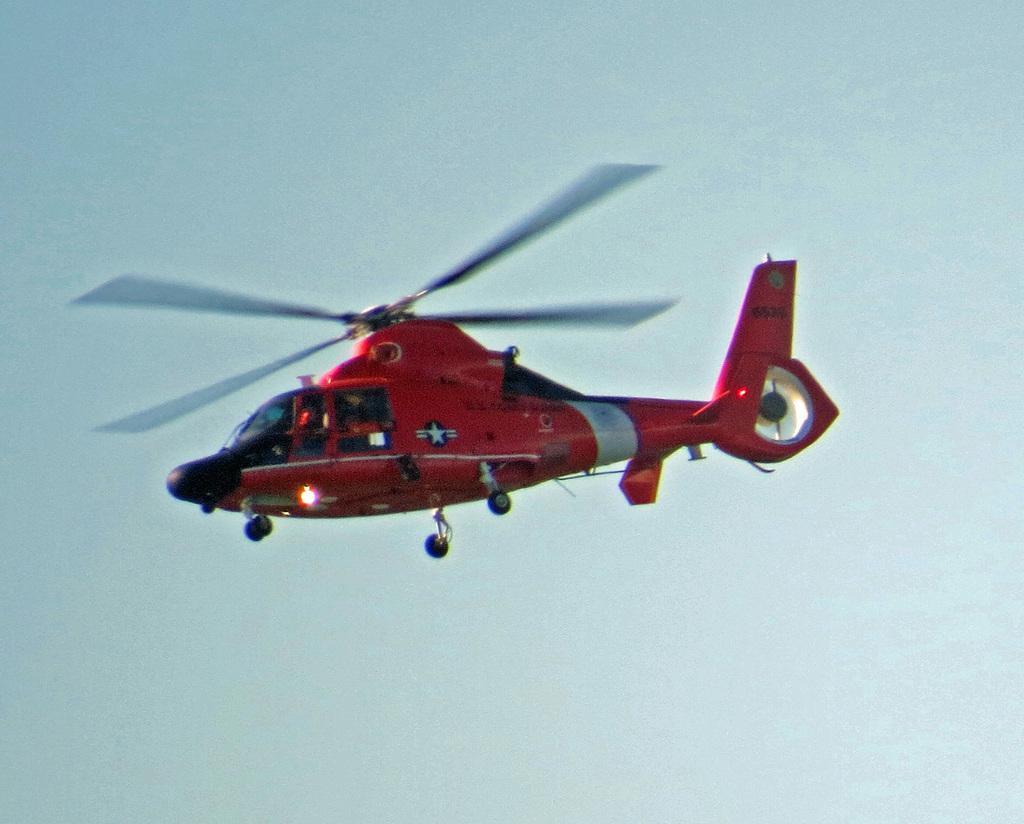Could you give a brief overview of what you see in this image? In this image I can see a red color helicopter is flying in the air towards the left side. On the top of the image I can see the sky. 